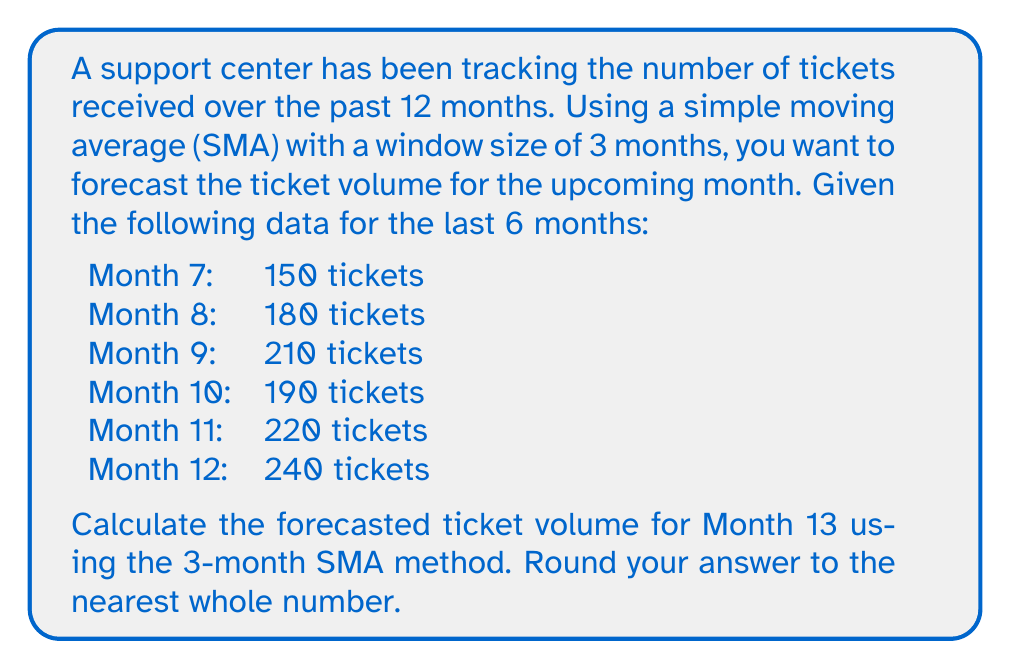Help me with this question. To solve this problem, we'll follow these steps:

1. Understand the Simple Moving Average (SMA) method:
   The 3-month SMA is calculated by taking the average of the last 3 months' data.

2. Identify the relevant data points:
   We need the data for months 10, 11, and 12 to calculate the forecast for month 13.

3. Calculate the 3-month SMA:
   $$SMA = \frac{Month_{10} + Month_{11} + Month_{12}}{3}$$

4. Plug in the values:
   $$SMA = \frac{190 + 220 + 240}{3}$$

5. Perform the calculation:
   $$SMA = \frac{650}{3} = 216.67$$

6. Round to the nearest whole number:
   216.67 rounds to 217

The forecasted ticket volume for Month 13 is 217 tickets.
Answer: 217 tickets 